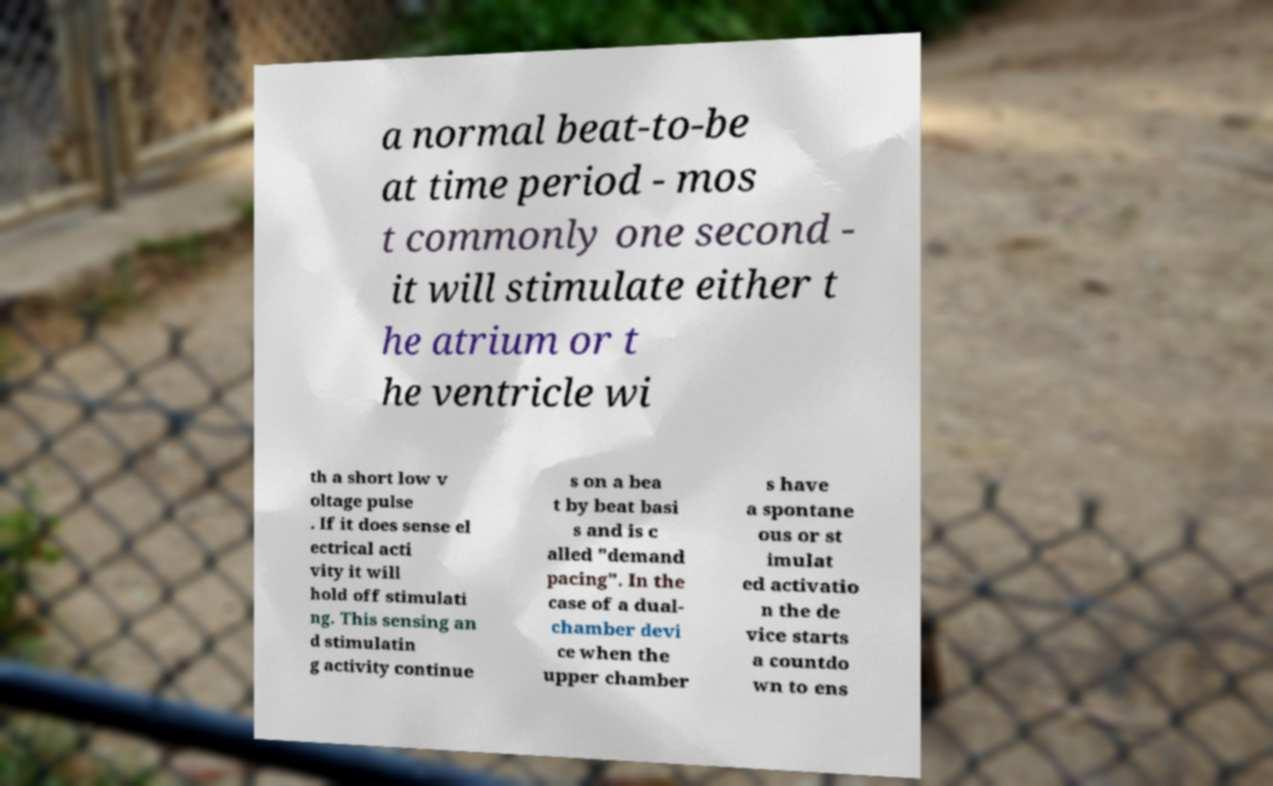Could you assist in decoding the text presented in this image and type it out clearly? a normal beat-to-be at time period - mos t commonly one second - it will stimulate either t he atrium or t he ventricle wi th a short low v oltage pulse . If it does sense el ectrical acti vity it will hold off stimulati ng. This sensing an d stimulatin g activity continue s on a bea t by beat basi s and is c alled "demand pacing". In the case of a dual- chamber devi ce when the upper chamber s have a spontane ous or st imulat ed activatio n the de vice starts a countdo wn to ens 